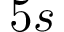<formula> <loc_0><loc_0><loc_500><loc_500>5 s</formula> 